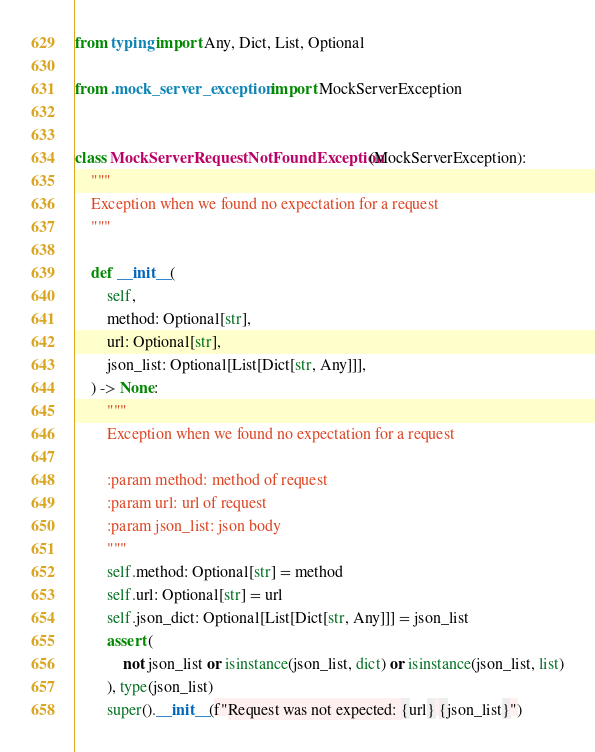<code> <loc_0><loc_0><loc_500><loc_500><_Python_>from typing import Any, Dict, List, Optional

from .mock_server_exception import MockServerException


class MockServerRequestNotFoundException(MockServerException):
    """
    Exception when we found no expectation for a request
    """

    def __init__(
        self,
        method: Optional[str],
        url: Optional[str],
        json_list: Optional[List[Dict[str, Any]]],
    ) -> None:
        """
        Exception when we found no expectation for a request

        :param method: method of request
        :param url: url of request
        :param json_list: json body
        """
        self.method: Optional[str] = method
        self.url: Optional[str] = url
        self.json_dict: Optional[List[Dict[str, Any]]] = json_list
        assert (
            not json_list or isinstance(json_list, dict) or isinstance(json_list, list)
        ), type(json_list)
        super().__init__(f"Request was not expected: {url} {json_list}")
</code> 